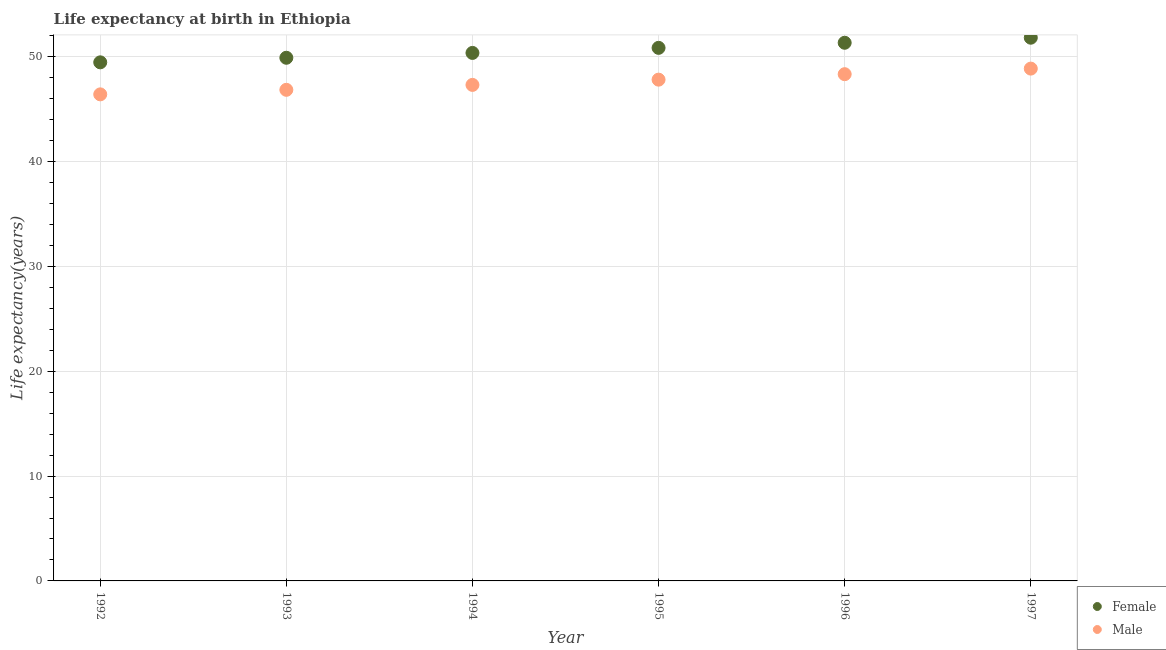How many different coloured dotlines are there?
Offer a terse response. 2. Is the number of dotlines equal to the number of legend labels?
Make the answer very short. Yes. What is the life expectancy(female) in 1997?
Give a very brief answer. 51.83. Across all years, what is the maximum life expectancy(male)?
Give a very brief answer. 48.88. Across all years, what is the minimum life expectancy(female)?
Offer a very short reply. 49.48. In which year was the life expectancy(female) minimum?
Ensure brevity in your answer.  1992. What is the total life expectancy(female) in the graph?
Your answer should be very brief. 303.8. What is the difference between the life expectancy(female) in 1993 and that in 1996?
Offer a very short reply. -1.43. What is the difference between the life expectancy(male) in 1994 and the life expectancy(female) in 1995?
Provide a succinct answer. -3.53. What is the average life expectancy(female) per year?
Provide a succinct answer. 50.63. In the year 1997, what is the difference between the life expectancy(male) and life expectancy(female)?
Give a very brief answer. -2.95. In how many years, is the life expectancy(female) greater than 42 years?
Your answer should be very brief. 6. What is the ratio of the life expectancy(male) in 1992 to that in 1993?
Your answer should be very brief. 0.99. Is the difference between the life expectancy(female) in 1994 and 1997 greater than the difference between the life expectancy(male) in 1994 and 1997?
Make the answer very short. Yes. What is the difference between the highest and the second highest life expectancy(male)?
Ensure brevity in your answer.  0.53. What is the difference between the highest and the lowest life expectancy(female)?
Your answer should be compact. 2.35. In how many years, is the life expectancy(male) greater than the average life expectancy(male) taken over all years?
Offer a terse response. 3. Is the sum of the life expectancy(male) in 1993 and 1995 greater than the maximum life expectancy(female) across all years?
Offer a terse response. Yes. Does the life expectancy(male) monotonically increase over the years?
Offer a terse response. Yes. Is the life expectancy(female) strictly greater than the life expectancy(male) over the years?
Keep it short and to the point. Yes. How many years are there in the graph?
Provide a succinct answer. 6. What is the difference between two consecutive major ticks on the Y-axis?
Your answer should be compact. 10. Are the values on the major ticks of Y-axis written in scientific E-notation?
Your answer should be compact. No. Does the graph contain grids?
Provide a succinct answer. Yes. Where does the legend appear in the graph?
Offer a very short reply. Bottom right. What is the title of the graph?
Give a very brief answer. Life expectancy at birth in Ethiopia. What is the label or title of the X-axis?
Offer a terse response. Year. What is the label or title of the Y-axis?
Offer a terse response. Life expectancy(years). What is the Life expectancy(years) of Female in 1992?
Offer a very short reply. 49.48. What is the Life expectancy(years) of Male in 1992?
Give a very brief answer. 46.42. What is the Life expectancy(years) of Female in 1993?
Ensure brevity in your answer.  49.91. What is the Life expectancy(years) in Male in 1993?
Give a very brief answer. 46.86. What is the Life expectancy(years) in Female in 1994?
Keep it short and to the point. 50.38. What is the Life expectancy(years) in Male in 1994?
Offer a very short reply. 47.33. What is the Life expectancy(years) in Female in 1995?
Your response must be concise. 50.86. What is the Life expectancy(years) of Male in 1995?
Ensure brevity in your answer.  47.83. What is the Life expectancy(years) in Female in 1996?
Provide a short and direct response. 51.34. What is the Life expectancy(years) in Male in 1996?
Make the answer very short. 48.35. What is the Life expectancy(years) in Female in 1997?
Your answer should be very brief. 51.83. What is the Life expectancy(years) of Male in 1997?
Offer a terse response. 48.88. Across all years, what is the maximum Life expectancy(years) in Female?
Ensure brevity in your answer.  51.83. Across all years, what is the maximum Life expectancy(years) in Male?
Your answer should be compact. 48.88. Across all years, what is the minimum Life expectancy(years) in Female?
Your answer should be compact. 49.48. Across all years, what is the minimum Life expectancy(years) of Male?
Your answer should be compact. 46.42. What is the total Life expectancy(years) in Female in the graph?
Your answer should be very brief. 303.8. What is the total Life expectancy(years) of Male in the graph?
Give a very brief answer. 285.66. What is the difference between the Life expectancy(years) in Female in 1992 and that in 1993?
Ensure brevity in your answer.  -0.44. What is the difference between the Life expectancy(years) of Male in 1992 and that in 1993?
Offer a terse response. -0.43. What is the difference between the Life expectancy(years) in Female in 1992 and that in 1994?
Your answer should be very brief. -0.9. What is the difference between the Life expectancy(years) in Male in 1992 and that in 1994?
Your response must be concise. -0.9. What is the difference between the Life expectancy(years) in Female in 1992 and that in 1995?
Provide a succinct answer. -1.38. What is the difference between the Life expectancy(years) of Male in 1992 and that in 1995?
Make the answer very short. -1.4. What is the difference between the Life expectancy(years) of Female in 1992 and that in 1996?
Ensure brevity in your answer.  -1.87. What is the difference between the Life expectancy(years) in Male in 1992 and that in 1996?
Your answer should be very brief. -1.93. What is the difference between the Life expectancy(years) in Female in 1992 and that in 1997?
Make the answer very short. -2.35. What is the difference between the Life expectancy(years) in Male in 1992 and that in 1997?
Offer a terse response. -2.46. What is the difference between the Life expectancy(years) in Female in 1993 and that in 1994?
Give a very brief answer. -0.46. What is the difference between the Life expectancy(years) in Male in 1993 and that in 1994?
Make the answer very short. -0.47. What is the difference between the Life expectancy(years) of Female in 1993 and that in 1995?
Offer a very short reply. -0.94. What is the difference between the Life expectancy(years) in Male in 1993 and that in 1995?
Give a very brief answer. -0.97. What is the difference between the Life expectancy(years) in Female in 1993 and that in 1996?
Ensure brevity in your answer.  -1.43. What is the difference between the Life expectancy(years) in Male in 1993 and that in 1996?
Offer a very short reply. -1.49. What is the difference between the Life expectancy(years) of Female in 1993 and that in 1997?
Your answer should be compact. -1.91. What is the difference between the Life expectancy(years) in Male in 1993 and that in 1997?
Make the answer very short. -2.02. What is the difference between the Life expectancy(years) in Female in 1994 and that in 1995?
Keep it short and to the point. -0.48. What is the difference between the Life expectancy(years) of Male in 1994 and that in 1995?
Offer a terse response. -0.5. What is the difference between the Life expectancy(years) of Female in 1994 and that in 1996?
Offer a very short reply. -0.97. What is the difference between the Life expectancy(years) in Male in 1994 and that in 1996?
Keep it short and to the point. -1.02. What is the difference between the Life expectancy(years) of Female in 1994 and that in 1997?
Provide a succinct answer. -1.45. What is the difference between the Life expectancy(years) of Male in 1994 and that in 1997?
Your answer should be very brief. -1.55. What is the difference between the Life expectancy(years) in Female in 1995 and that in 1996?
Your response must be concise. -0.49. What is the difference between the Life expectancy(years) in Male in 1995 and that in 1996?
Your answer should be very brief. -0.52. What is the difference between the Life expectancy(years) in Female in 1995 and that in 1997?
Give a very brief answer. -0.97. What is the difference between the Life expectancy(years) of Male in 1995 and that in 1997?
Your response must be concise. -1.05. What is the difference between the Life expectancy(years) of Female in 1996 and that in 1997?
Offer a very short reply. -0.48. What is the difference between the Life expectancy(years) of Male in 1996 and that in 1997?
Your answer should be very brief. -0.53. What is the difference between the Life expectancy(years) of Female in 1992 and the Life expectancy(years) of Male in 1993?
Provide a succinct answer. 2.62. What is the difference between the Life expectancy(years) in Female in 1992 and the Life expectancy(years) in Male in 1994?
Offer a very short reply. 2.15. What is the difference between the Life expectancy(years) of Female in 1992 and the Life expectancy(years) of Male in 1995?
Keep it short and to the point. 1.65. What is the difference between the Life expectancy(years) in Female in 1992 and the Life expectancy(years) in Male in 1996?
Your answer should be very brief. 1.13. What is the difference between the Life expectancy(years) in Female in 1992 and the Life expectancy(years) in Male in 1997?
Provide a succinct answer. 0.6. What is the difference between the Life expectancy(years) of Female in 1993 and the Life expectancy(years) of Male in 1994?
Your response must be concise. 2.59. What is the difference between the Life expectancy(years) in Female in 1993 and the Life expectancy(years) in Male in 1995?
Your answer should be compact. 2.09. What is the difference between the Life expectancy(years) of Female in 1993 and the Life expectancy(years) of Male in 1996?
Give a very brief answer. 1.57. What is the difference between the Life expectancy(years) of Female in 1993 and the Life expectancy(years) of Male in 1997?
Provide a succinct answer. 1.03. What is the difference between the Life expectancy(years) in Female in 1994 and the Life expectancy(years) in Male in 1995?
Offer a very short reply. 2.55. What is the difference between the Life expectancy(years) in Female in 1994 and the Life expectancy(years) in Male in 1996?
Make the answer very short. 2.03. What is the difference between the Life expectancy(years) in Female in 1994 and the Life expectancy(years) in Male in 1997?
Give a very brief answer. 1.5. What is the difference between the Life expectancy(years) in Female in 1995 and the Life expectancy(years) in Male in 1996?
Ensure brevity in your answer.  2.51. What is the difference between the Life expectancy(years) of Female in 1995 and the Life expectancy(years) of Male in 1997?
Your response must be concise. 1.98. What is the difference between the Life expectancy(years) in Female in 1996 and the Life expectancy(years) in Male in 1997?
Offer a very short reply. 2.46. What is the average Life expectancy(years) in Female per year?
Ensure brevity in your answer.  50.63. What is the average Life expectancy(years) of Male per year?
Your answer should be very brief. 47.61. In the year 1992, what is the difference between the Life expectancy(years) of Female and Life expectancy(years) of Male?
Offer a terse response. 3.06. In the year 1993, what is the difference between the Life expectancy(years) of Female and Life expectancy(years) of Male?
Give a very brief answer. 3.06. In the year 1994, what is the difference between the Life expectancy(years) in Female and Life expectancy(years) in Male?
Your response must be concise. 3.05. In the year 1995, what is the difference between the Life expectancy(years) of Female and Life expectancy(years) of Male?
Provide a succinct answer. 3.03. In the year 1996, what is the difference between the Life expectancy(years) of Female and Life expectancy(years) of Male?
Provide a short and direct response. 3. In the year 1997, what is the difference between the Life expectancy(years) in Female and Life expectancy(years) in Male?
Your response must be concise. 2.95. What is the ratio of the Life expectancy(years) of Female in 1992 to that in 1993?
Make the answer very short. 0.99. What is the ratio of the Life expectancy(years) in Female in 1992 to that in 1994?
Your answer should be very brief. 0.98. What is the ratio of the Life expectancy(years) of Male in 1992 to that in 1994?
Keep it short and to the point. 0.98. What is the ratio of the Life expectancy(years) in Female in 1992 to that in 1995?
Your response must be concise. 0.97. What is the ratio of the Life expectancy(years) in Male in 1992 to that in 1995?
Ensure brevity in your answer.  0.97. What is the ratio of the Life expectancy(years) of Female in 1992 to that in 1996?
Keep it short and to the point. 0.96. What is the ratio of the Life expectancy(years) in Male in 1992 to that in 1996?
Keep it short and to the point. 0.96. What is the ratio of the Life expectancy(years) of Female in 1992 to that in 1997?
Offer a terse response. 0.95. What is the ratio of the Life expectancy(years) in Male in 1992 to that in 1997?
Your answer should be very brief. 0.95. What is the ratio of the Life expectancy(years) in Female in 1993 to that in 1995?
Your response must be concise. 0.98. What is the ratio of the Life expectancy(years) of Male in 1993 to that in 1995?
Give a very brief answer. 0.98. What is the ratio of the Life expectancy(years) of Female in 1993 to that in 1996?
Keep it short and to the point. 0.97. What is the ratio of the Life expectancy(years) in Male in 1993 to that in 1996?
Your answer should be compact. 0.97. What is the ratio of the Life expectancy(years) in Female in 1993 to that in 1997?
Keep it short and to the point. 0.96. What is the ratio of the Life expectancy(years) in Male in 1993 to that in 1997?
Your response must be concise. 0.96. What is the ratio of the Life expectancy(years) in Male in 1994 to that in 1995?
Offer a terse response. 0.99. What is the ratio of the Life expectancy(years) in Female in 1994 to that in 1996?
Your answer should be very brief. 0.98. What is the ratio of the Life expectancy(years) in Male in 1994 to that in 1996?
Give a very brief answer. 0.98. What is the ratio of the Life expectancy(years) of Female in 1994 to that in 1997?
Your answer should be compact. 0.97. What is the ratio of the Life expectancy(years) in Male in 1994 to that in 1997?
Offer a very short reply. 0.97. What is the ratio of the Life expectancy(years) of Female in 1995 to that in 1996?
Ensure brevity in your answer.  0.99. What is the ratio of the Life expectancy(years) of Male in 1995 to that in 1996?
Provide a succinct answer. 0.99. What is the ratio of the Life expectancy(years) of Female in 1995 to that in 1997?
Make the answer very short. 0.98. What is the ratio of the Life expectancy(years) of Male in 1995 to that in 1997?
Provide a succinct answer. 0.98. What is the ratio of the Life expectancy(years) in Female in 1996 to that in 1997?
Ensure brevity in your answer.  0.99. What is the ratio of the Life expectancy(years) in Male in 1996 to that in 1997?
Offer a terse response. 0.99. What is the difference between the highest and the second highest Life expectancy(years) of Female?
Provide a short and direct response. 0.48. What is the difference between the highest and the second highest Life expectancy(years) of Male?
Provide a short and direct response. 0.53. What is the difference between the highest and the lowest Life expectancy(years) in Female?
Make the answer very short. 2.35. What is the difference between the highest and the lowest Life expectancy(years) in Male?
Your answer should be compact. 2.46. 